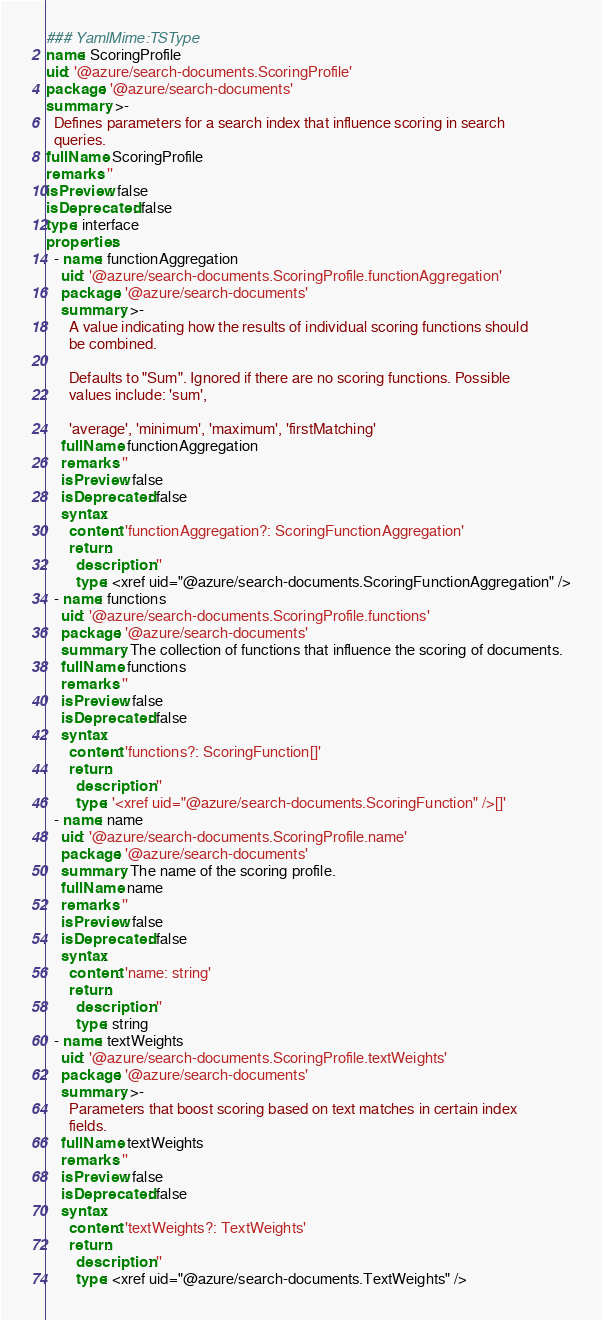Convert code to text. <code><loc_0><loc_0><loc_500><loc_500><_YAML_>### YamlMime:TSType
name: ScoringProfile
uid: '@azure/search-documents.ScoringProfile'
package: '@azure/search-documents'
summary: >-
  Defines parameters for a search index that influence scoring in search
  queries.
fullName: ScoringProfile
remarks: ''
isPreview: false
isDeprecated: false
type: interface
properties:
  - name: functionAggregation
    uid: '@azure/search-documents.ScoringProfile.functionAggregation'
    package: '@azure/search-documents'
    summary: >-
      A value indicating how the results of individual scoring functions should
      be combined.

      Defaults to "Sum". Ignored if there are no scoring functions. Possible
      values include: 'sum',

      'average', 'minimum', 'maximum', 'firstMatching'
    fullName: functionAggregation
    remarks: ''
    isPreview: false
    isDeprecated: false
    syntax:
      content: 'functionAggregation?: ScoringFunctionAggregation'
      return:
        description: ''
        type: <xref uid="@azure/search-documents.ScoringFunctionAggregation" />
  - name: functions
    uid: '@azure/search-documents.ScoringProfile.functions'
    package: '@azure/search-documents'
    summary: The collection of functions that influence the scoring of documents.
    fullName: functions
    remarks: ''
    isPreview: false
    isDeprecated: false
    syntax:
      content: 'functions?: ScoringFunction[]'
      return:
        description: ''
        type: '<xref uid="@azure/search-documents.ScoringFunction" />[]'
  - name: name
    uid: '@azure/search-documents.ScoringProfile.name'
    package: '@azure/search-documents'
    summary: The name of the scoring profile.
    fullName: name
    remarks: ''
    isPreview: false
    isDeprecated: false
    syntax:
      content: 'name: string'
      return:
        description: ''
        type: string
  - name: textWeights
    uid: '@azure/search-documents.ScoringProfile.textWeights'
    package: '@azure/search-documents'
    summary: >-
      Parameters that boost scoring based on text matches in certain index
      fields.
    fullName: textWeights
    remarks: ''
    isPreview: false
    isDeprecated: false
    syntax:
      content: 'textWeights?: TextWeights'
      return:
        description: ''
        type: <xref uid="@azure/search-documents.TextWeights" />
</code> 